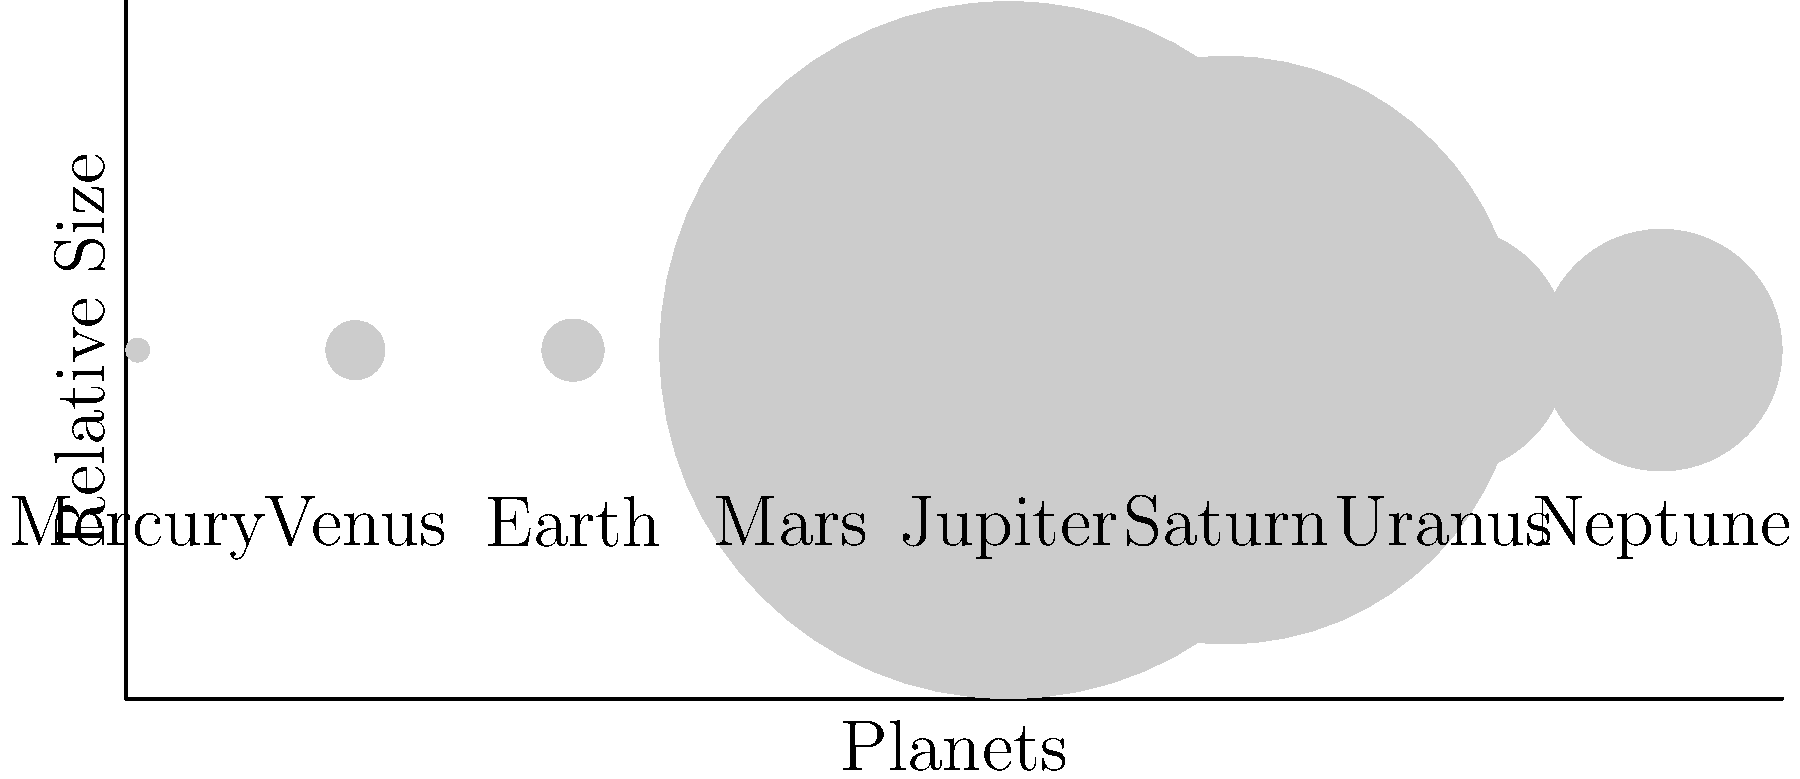In the context of Tolstoy's "War and Peace," where the vastness of Russia is often compared to the expansiveness of the universe, consider the relative sizes of planets in our solar system. Which planet, when juxtaposed with Earth's diameter, most closely mirrors the ratio between Napoleon's Grande Armée at its peak and Kutuzov's Russian forces at the Battle of Borodino? To answer this question, we need to follow these steps:

1. Recall the historical context:
   - Napoleon's Grande Armée at its peak: approximately 600,000 men
   - Kutuzov's Russian forces at Borodino: approximately 120,000 men

2. Calculate the ratio:
   $\frac{600,000}{120,000} = 5$

3. Examine the relative diameters of planets compared to Earth:
   - Mercury: 0.383
   - Venus: 0.949
   - Earth: 1 (reference)
   - Mars: 0.532
   - Jupiter: 11.209
   - Saturn: 9.449
   - Uranus: 4.007
   - Neptune: 3.883

4. Find the closest ratio to 5:
   Jupiter's diameter is 11.209 times that of Earth, which is the closest to the 5:1 ratio we're looking for.

5. Interpret the result:
   Just as Napoleon's army was about 5 times larger than Kutuzov's, Jupiter's diameter is about 11 times larger than Earth's, making it the closest analogy in our solar system to this historical comparison.
Answer: Jupiter 